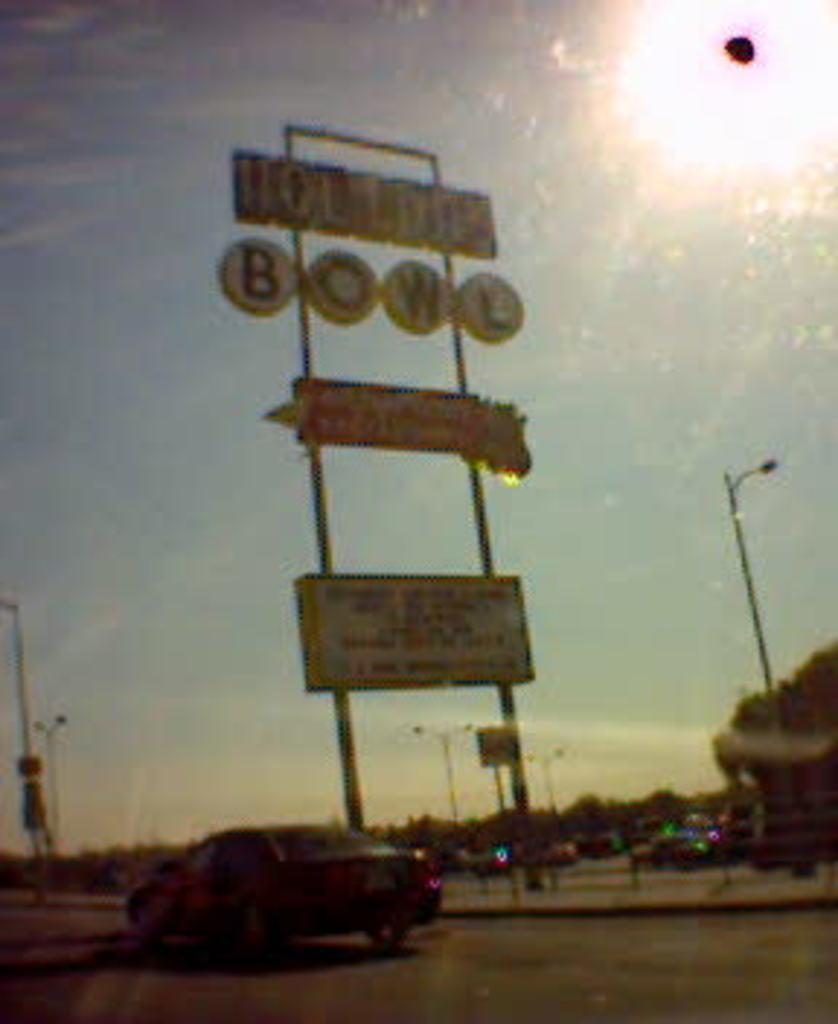Please provide a concise description of this image. In this picture we can see a vehicle on the path. There are a few boards visible on the poles. We can see a few trees in the background. 